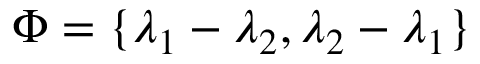Convert formula to latex. <formula><loc_0><loc_0><loc_500><loc_500>\Phi = \{ \lambda _ { 1 } - \lambda _ { 2 } , \lambda _ { 2 } - \lambda _ { 1 } \}</formula> 